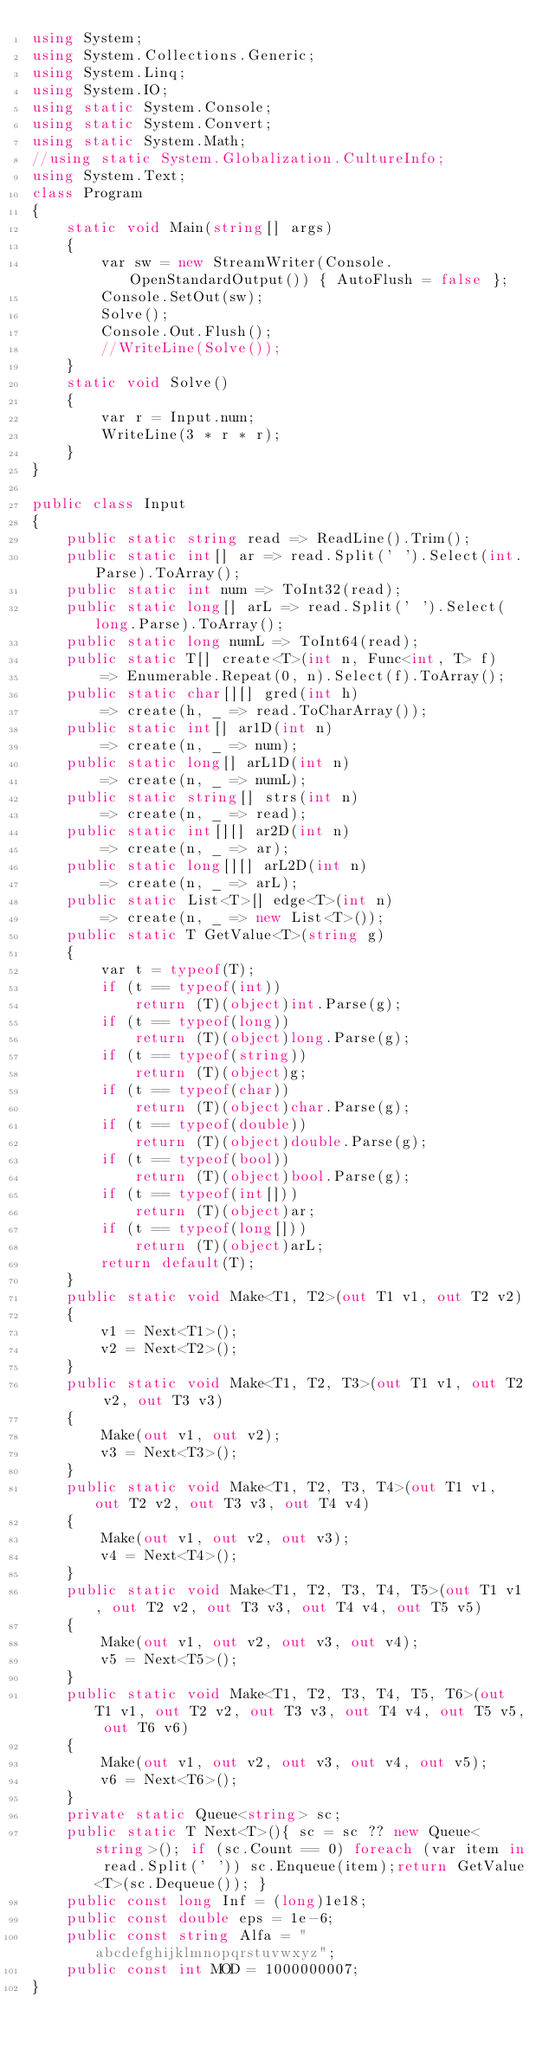Convert code to text. <code><loc_0><loc_0><loc_500><loc_500><_C#_>using System;
using System.Collections.Generic;
using System.Linq;
using System.IO;
using static System.Console;
using static System.Convert;
using static System.Math;
//using static System.Globalization.CultureInfo;
using System.Text;
class Program
{
    static void Main(string[] args)
    {
        var sw = new StreamWriter(Console.OpenStandardOutput()) { AutoFlush = false };
        Console.SetOut(sw);
        Solve();
        Console.Out.Flush();
        //WriteLine(Solve());
    }
    static void Solve()
    {
        var r = Input.num;
        WriteLine(3 * r * r);
    }
}

public class Input
{
    public static string read => ReadLine().Trim();
    public static int[] ar => read.Split(' ').Select(int.Parse).ToArray();
    public static int num => ToInt32(read);
    public static long[] arL => read.Split(' ').Select(long.Parse).ToArray();
    public static long numL => ToInt64(read);
    public static T[] create<T>(int n, Func<int, T> f)
        => Enumerable.Repeat(0, n).Select(f).ToArray();
    public static char[][] gred(int h)
        => create(h, _ => read.ToCharArray());
    public static int[] ar1D(int n)
        => create(n, _ => num);
    public static long[] arL1D(int n)
        => create(n, _ => numL);
    public static string[] strs(int n)
        => create(n, _ => read);
    public static int[][] ar2D(int n)
        => create(n, _ => ar);
    public static long[][] arL2D(int n)
        => create(n, _ => arL);
    public static List<T>[] edge<T>(int n)
        => create(n, _ => new List<T>());
    public static T GetValue<T>(string g)
    {
        var t = typeof(T);
        if (t == typeof(int))
            return (T)(object)int.Parse(g);
        if (t == typeof(long))
            return (T)(object)long.Parse(g);
        if (t == typeof(string))
            return (T)(object)g;
        if (t == typeof(char))
            return (T)(object)char.Parse(g);
        if (t == typeof(double))
            return (T)(object)double.Parse(g);
        if (t == typeof(bool))
            return (T)(object)bool.Parse(g);
        if (t == typeof(int[]))
            return (T)(object)ar;
        if (t == typeof(long[]))
            return (T)(object)arL;
        return default(T);
    }
    public static void Make<T1, T2>(out T1 v1, out T2 v2)
    {
        v1 = Next<T1>();
        v2 = Next<T2>();
    }
    public static void Make<T1, T2, T3>(out T1 v1, out T2 v2, out T3 v3)
    {
        Make(out v1, out v2);
        v3 = Next<T3>();
    }
    public static void Make<T1, T2, T3, T4>(out T1 v1, out T2 v2, out T3 v3, out T4 v4)
    {
        Make(out v1, out v2, out v3);
        v4 = Next<T4>();
    }
    public static void Make<T1, T2, T3, T4, T5>(out T1 v1, out T2 v2, out T3 v3, out T4 v4, out T5 v5)
    {
        Make(out v1, out v2, out v3, out v4);
        v5 = Next<T5>();
    }
    public static void Make<T1, T2, T3, T4, T5, T6>(out T1 v1, out T2 v2, out T3 v3, out T4 v4, out T5 v5, out T6 v6)
    {
        Make(out v1, out v2, out v3, out v4, out v5);
        v6 = Next<T6>();
    }
    private static Queue<string> sc;
    public static T Next<T>(){ sc = sc ?? new Queue<string>(); if (sc.Count == 0) foreach (var item in read.Split(' ')) sc.Enqueue(item);return GetValue<T>(sc.Dequeue()); }
    public const long Inf = (long)1e18;
    public const double eps = 1e-6;
    public const string Alfa = "abcdefghijklmnopqrstuvwxyz";
    public const int MOD = 1000000007;
}
</code> 